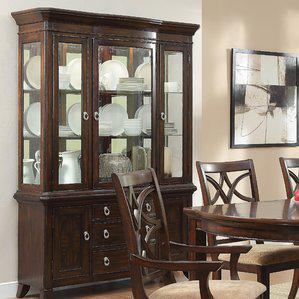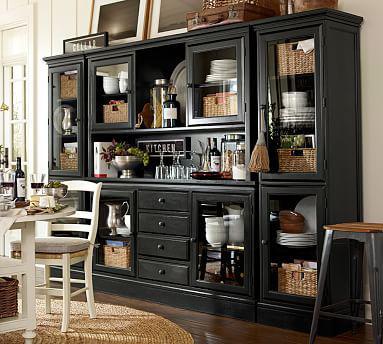The first image is the image on the left, the second image is the image on the right. Evaluate the accuracy of this statement regarding the images: "the background has one picture hanging on the wall". Is it true? Answer yes or no. Yes. The first image is the image on the left, the second image is the image on the right. Given the left and right images, does the statement "In one image in each pair there is white pottery on top of the china cabinet." hold true? Answer yes or no. No. 